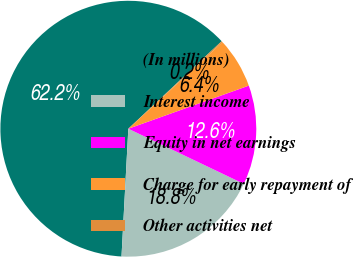Convert chart. <chart><loc_0><loc_0><loc_500><loc_500><pie_chart><fcel>(In millions)<fcel>Interest income<fcel>Equity in net earnings<fcel>Charge for early repayment of<fcel>Other activities net<nl><fcel>62.17%<fcel>18.76%<fcel>12.56%<fcel>6.36%<fcel>0.16%<nl></chart> 